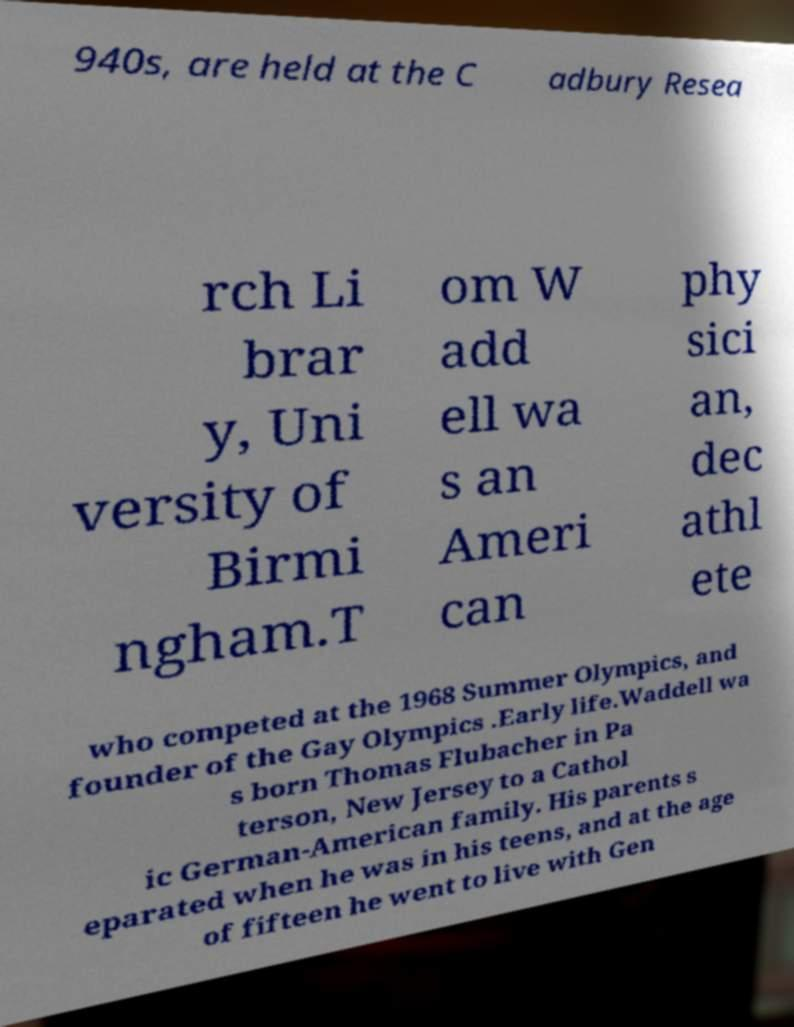For documentation purposes, I need the text within this image transcribed. Could you provide that? 940s, are held at the C adbury Resea rch Li brar y, Uni versity of Birmi ngham.T om W add ell wa s an Ameri can phy sici an, dec athl ete who competed at the 1968 Summer Olympics, and founder of the Gay Olympics .Early life.Waddell wa s born Thomas Flubacher in Pa terson, New Jersey to a Cathol ic German-American family. His parents s eparated when he was in his teens, and at the age of fifteen he went to live with Gen 